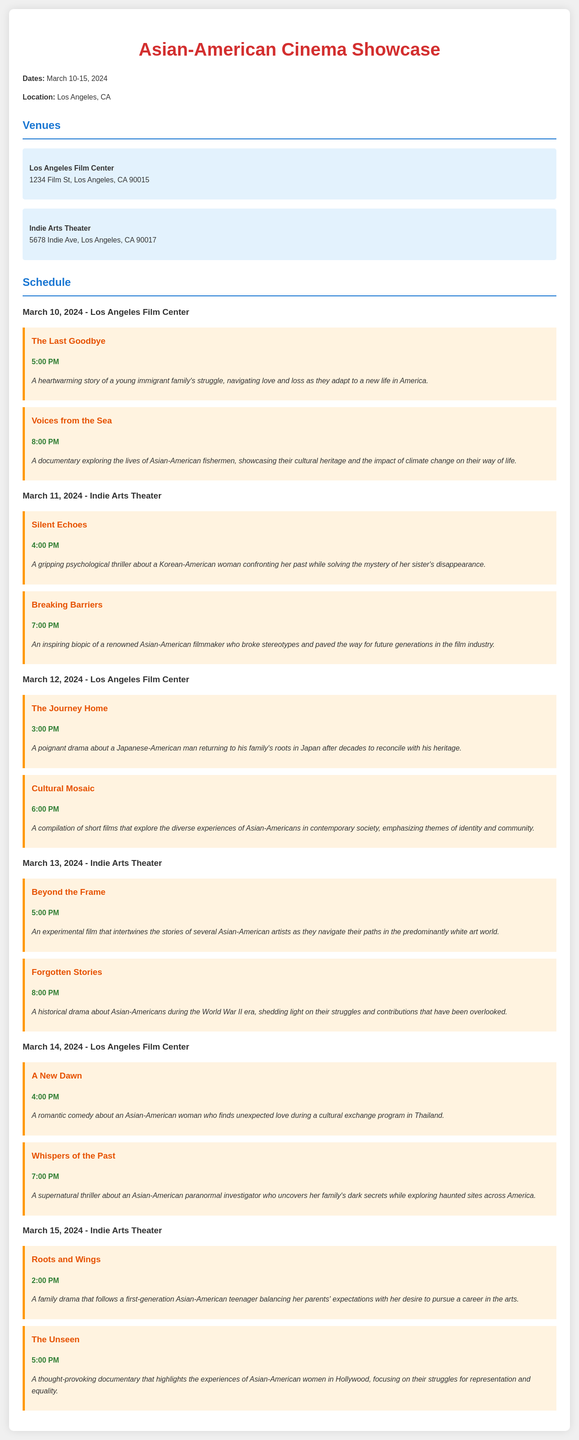what are the dates of the festival? The dates of the festival are mentioned at the beginning of the document.
Answer: March 10-15, 2024 how many films are screened on March 12, 2024? The number of films is determined by counting the screenings listed for that date in the document.
Answer: 2 what is the title of the film screening at 7:00 PM on March 14, 2024? The title can be found by referring to the screening schedule and the specified time.
Answer: Whispers of the Past where is the Los Angeles Film Center located? The location is provided in the venue section of the document.
Answer: 1234 Film St, Los Angeles, CA 90015 which film is a romantic comedy? The genre description can be derived from the synopsis of the films listed.
Answer: A New Dawn who is the focus of the documentary "The Unseen"? The subject of the documentary is mentioned in the synopsis.
Answer: Asian-American women in Hollywood what type of film is "Silent Echoes"? The type of film can be identified from its description in the screening section.
Answer: Psychological thriller how many screenings are held at Indie Arts Theater? This can be calculated by counting the screenings listed for both dates at that venue.
Answer: 6 